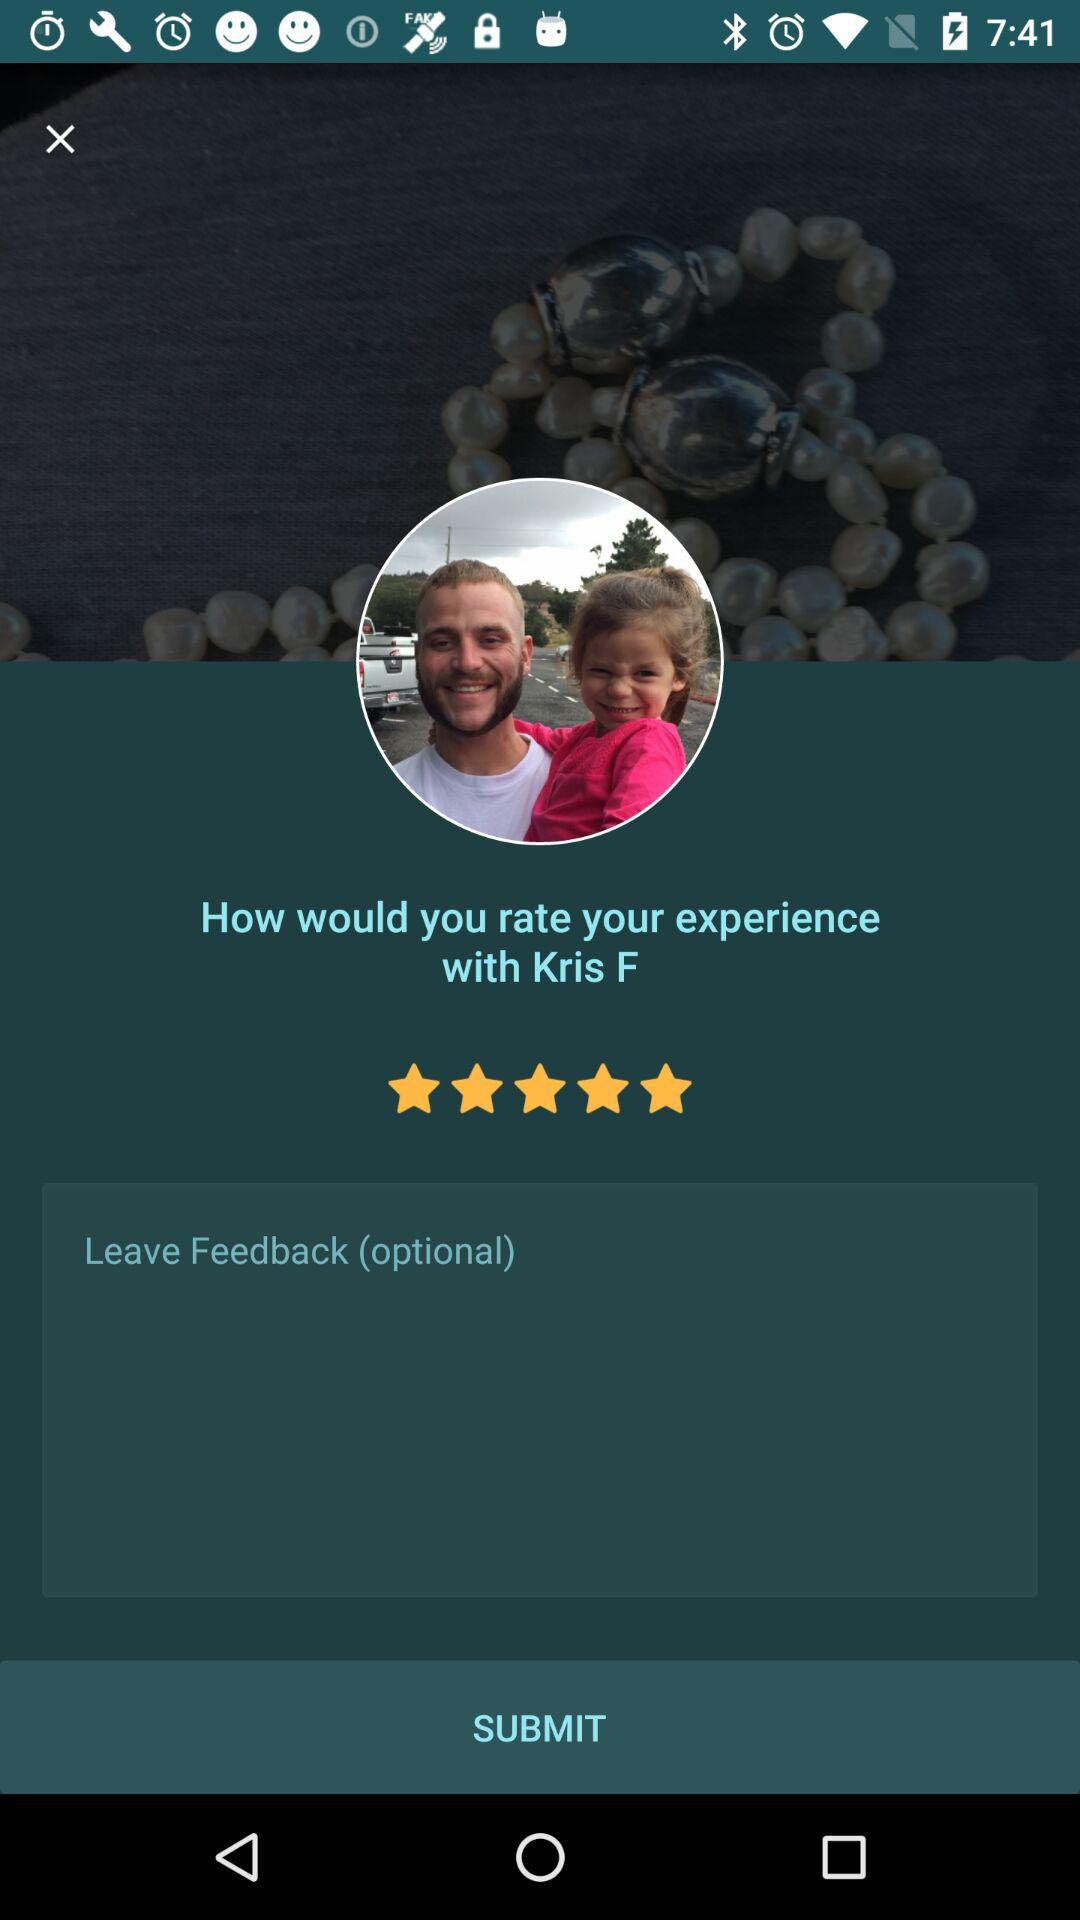What is the given rating? The given rating is 5 stars. 